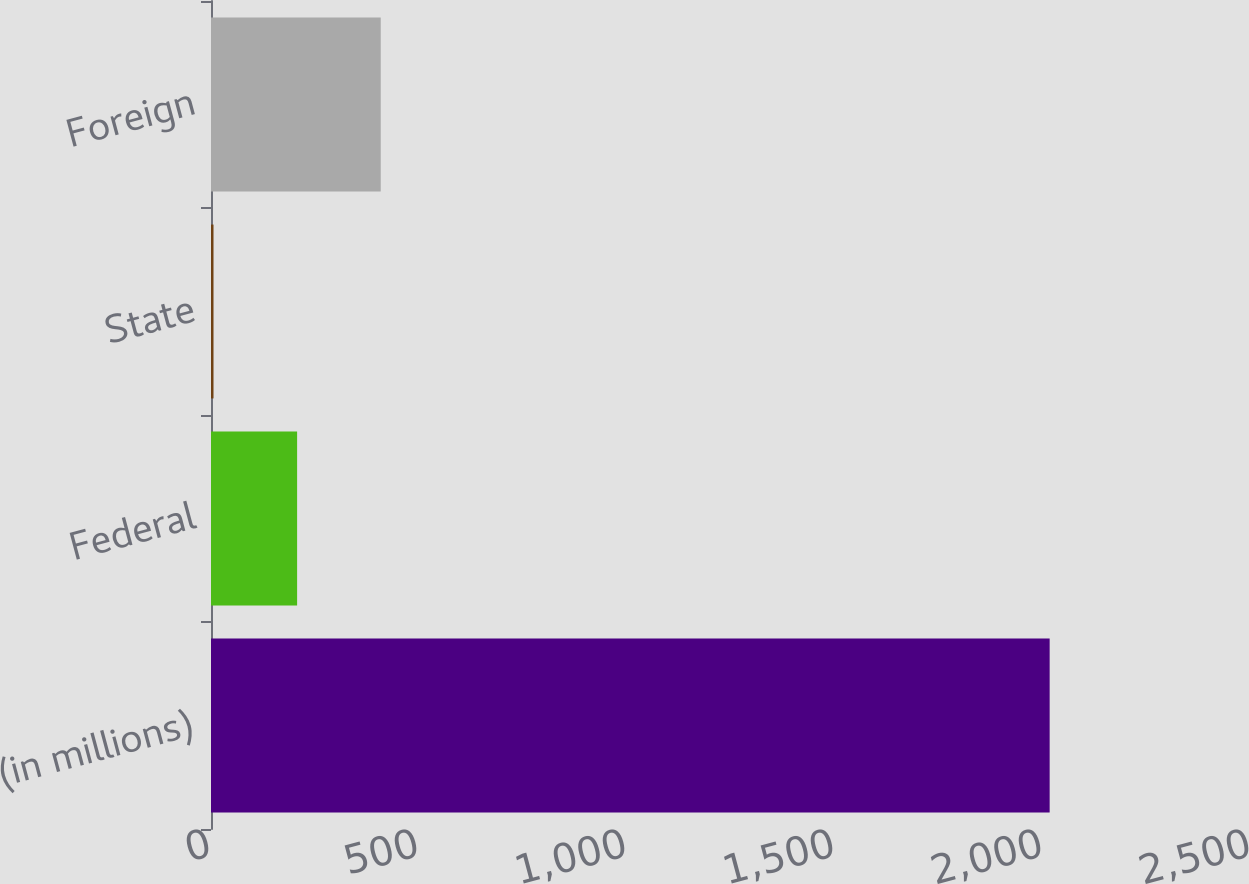Convert chart to OTSL. <chart><loc_0><loc_0><loc_500><loc_500><bar_chart><fcel>(in millions)<fcel>Federal<fcel>State<fcel>Foreign<nl><fcel>2016<fcel>207<fcel>6<fcel>408<nl></chart> 